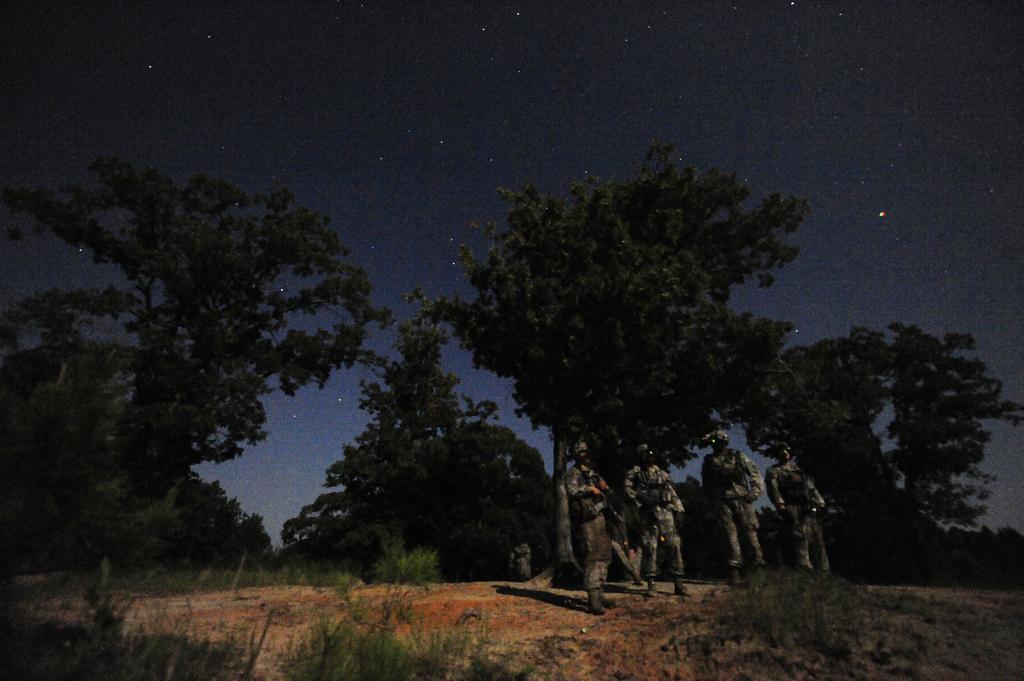Can you describe this image briefly? In this picture, we can see a few soldiers holding some objects, we can see the ground with grass, plants, trees, and the dark sky, and stars. 